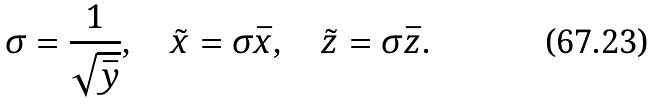<formula> <loc_0><loc_0><loc_500><loc_500>\sigma = \frac { 1 } { \sqrt { \bar { y } } } , \quad \tilde { x } = \sigma \bar { x } , \quad \tilde { z } = \sigma \bar { z } .</formula> 